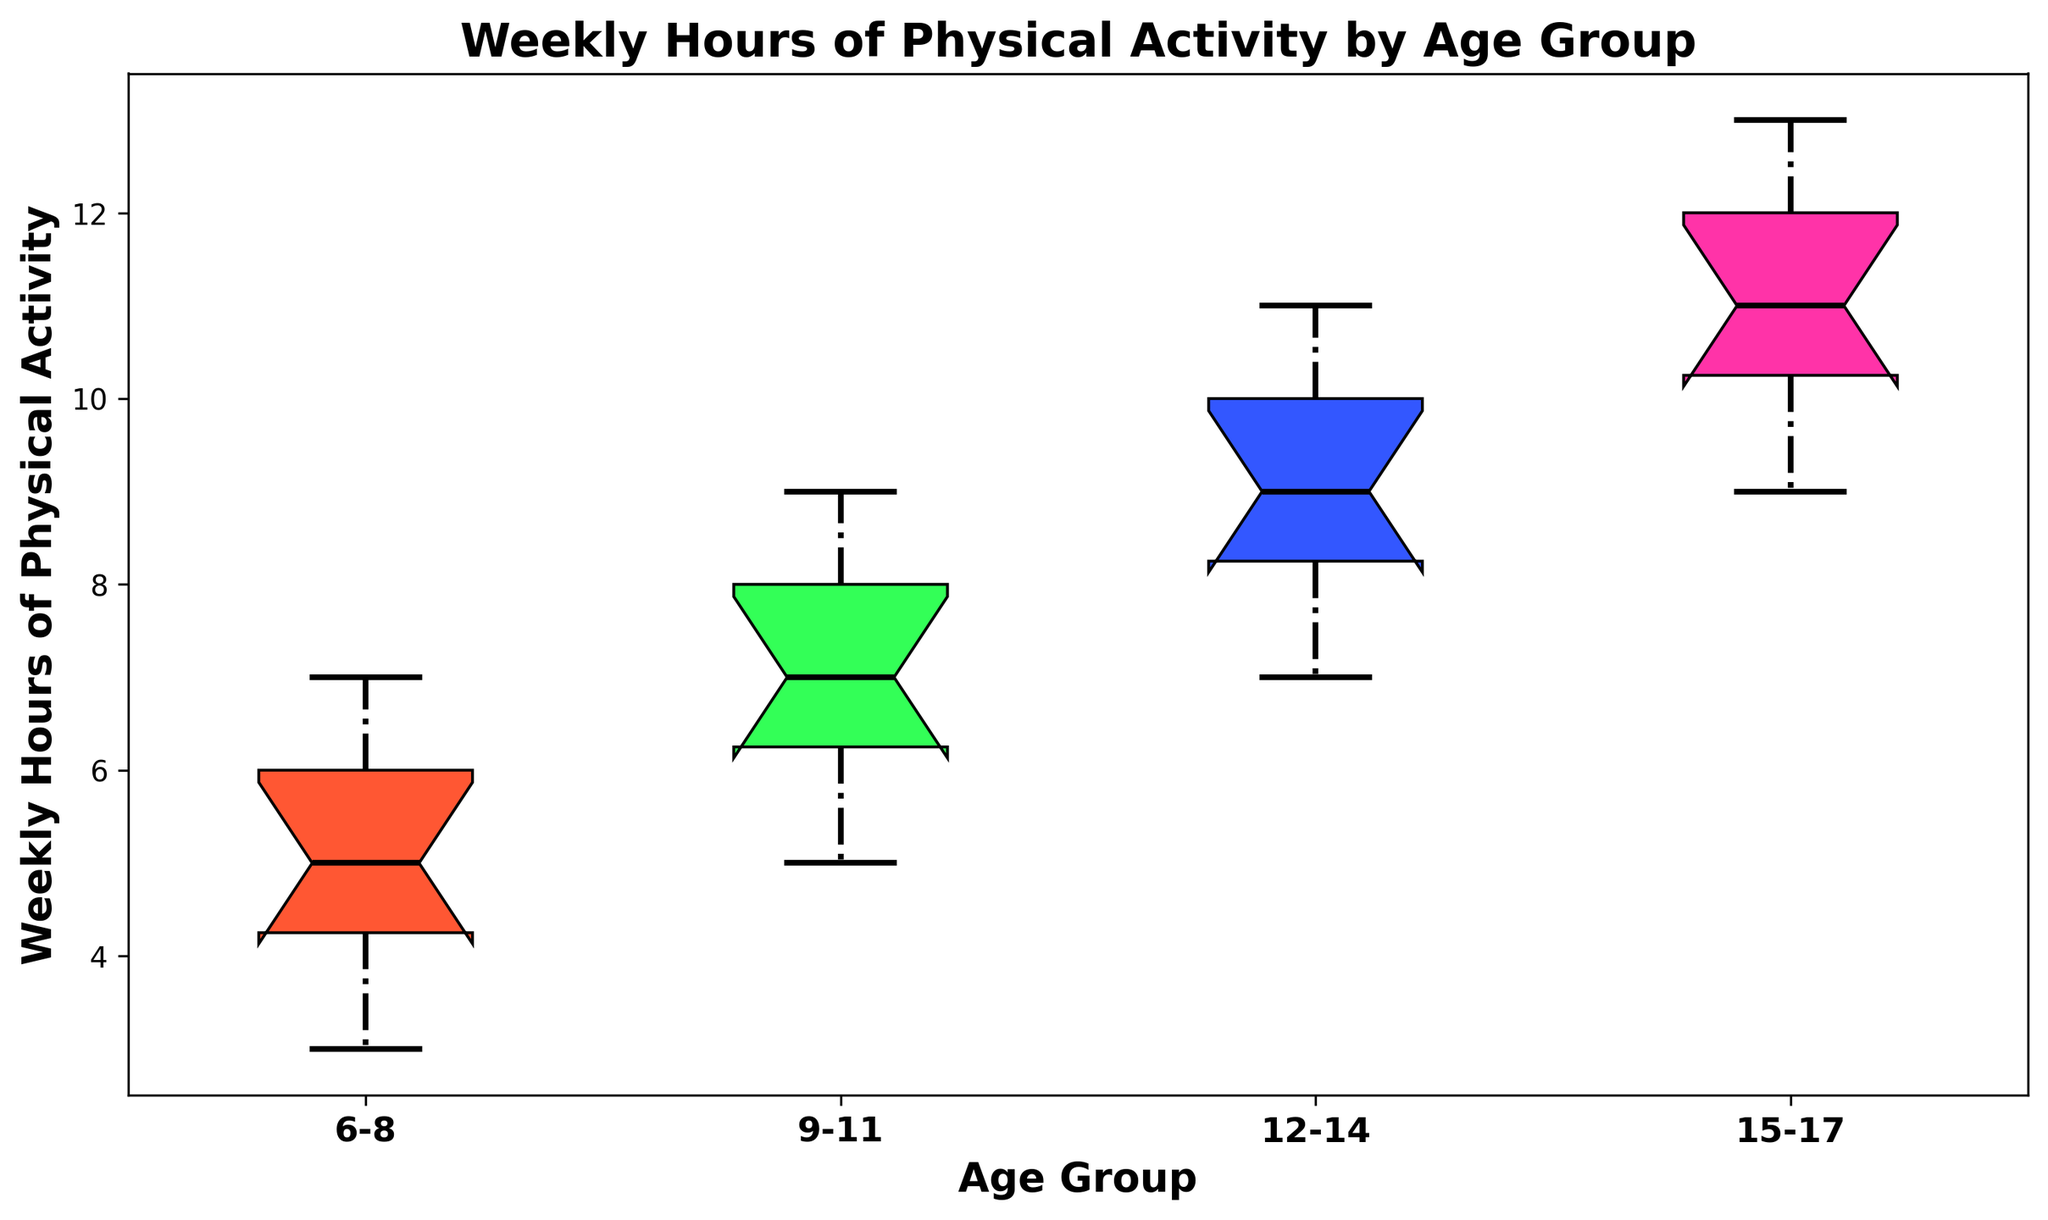What is the median weekly hours of physical activity for the 9-11 age group? The median is the middle value of the dataset when ordered. For the 9-11 age group, the weekly hours are 5, 6, 6, 7, 7, 7, 8, 8, 8, and 9. The median is the average of the 5th and 6th values: (7+7)/2 = 7.
Answer: 7 Which age group has the highest median weekly hours of physical activity? The figure shows that the 15-17 age group has the highest median, as the line inside the box is at the highest position compared to other age groups.
Answer: 15-17 How does the interquartile range (IQR) of weekly hours of physical activity compare between the 6-8 and 12-14 age groups? The IQR is the range between the first quartile (Q1) and third quartile (Q3). In the figure, the height of the middle section (box) between Q1 and Q3 is wider for the 12-14 age group compared to the 6-8 age group.
Answer: IQR is wider for 12-14 Which age group has the smallest range of weekly hours of physical activity? The range is the difference between the maximum and minimum values. The 6-8 age group boxplot shows the shortest whiskers, indicating the smallest range.
Answer: 6-8 What is the upper quartile (Q3) for the weekly hours of physical activity for the 15-17 age group? The upper quartile (Q3) is the top of the box in the box plot. For the 15-17 age group, Q3 is at 12 hours.
Answer: 12 Is there any age group where the median weekly hours of physical activity is equal to the upper quartile (Q3) of another age group? By comparing the medians and Q3s in the figure, the median weekly hours for 12-14 (9 hours) equals the upper quartile (Q3) for the 6-8 age group.
Answer: Yes, 12-14 median equals 6-8 Q3 How does the distribution of weekly hours of physical activity vary among the age groups based on the box plot? The distribution varies as younger age groups (like 6-8) show lower medians and narrower ranges, while older age groups (like 12-14 and 15-17) show higher medians and wider ranges.
Answer: Varies with age In which age group(s) are the outliers most likely visible? Outliers are data points outside Q1 and Q3, and visible as points outside whiskers. The figure shows no such points, indicating no outliers in any group.
Answer: None Which age group shows the most consistency in weekly hours of physical activity? Consistency is indicated by the smallest variation. The 6-8 age group has the most compact box and whiskers, showing the least variation.
Answer: 6-8 